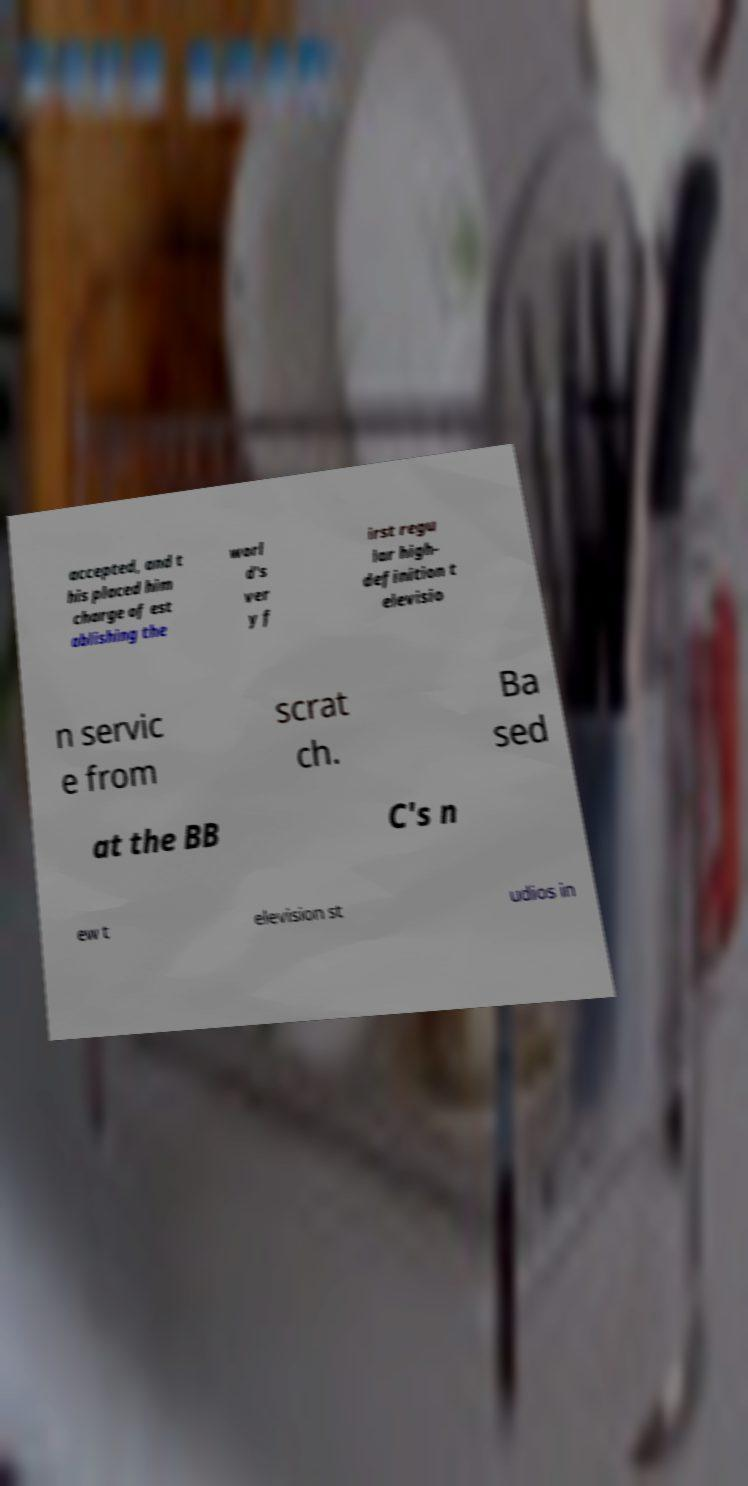Please identify and transcribe the text found in this image. accepted, and t his placed him charge of est ablishing the worl d's ver y f irst regu lar high- definition t elevisio n servic e from scrat ch. Ba sed at the BB C's n ew t elevision st udios in 